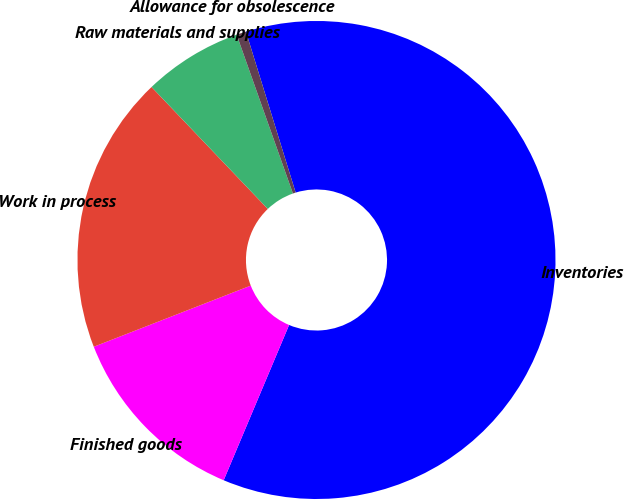Convert chart to OTSL. <chart><loc_0><loc_0><loc_500><loc_500><pie_chart><fcel>Inventories<fcel>Finished goods<fcel>Work in process<fcel>Raw materials and supplies<fcel>Allowance for obsolescence<nl><fcel>61.11%<fcel>12.74%<fcel>18.79%<fcel>6.7%<fcel>0.65%<nl></chart> 